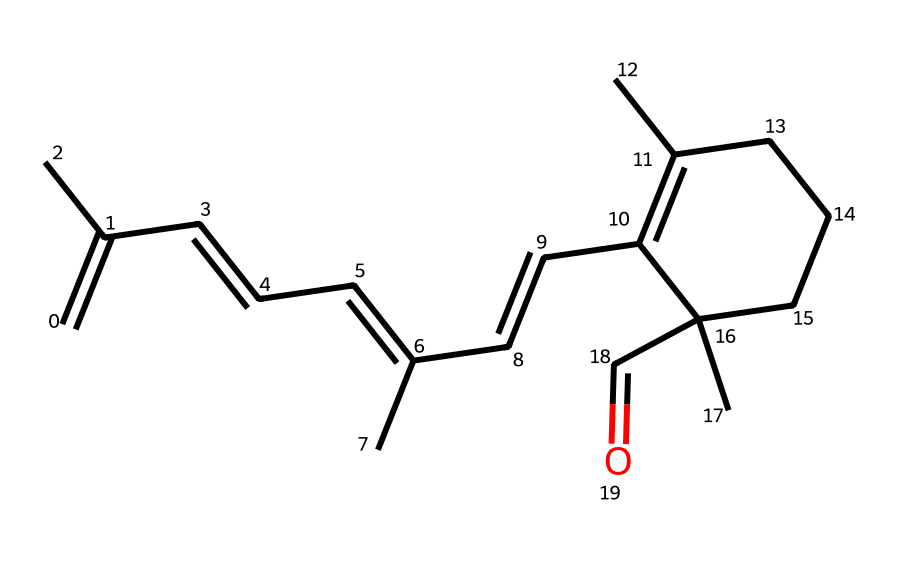What is the molecular formula of retinal? To determine the molecular formula from the SMILES representation, count the number of carbon (C), hydrogen (H), and oxygen (O) atoms. The structure has 21 carbons, 30 hydrogens, and 1 oxygen. Therefore, the molecular formula is C21H30O.
Answer: C21H30O How many double bonds are present in the structure? By analyzing the SMILES notation, we can identify the double bonds (C=C) in the structure. The structure has 5 instances of double bonds between carbon atoms.
Answer: 5 What type of functional group is present in retinal? The SMILES representation contains the fragment C=O, indicating the carbonyl group (C=O), which is characteristic of aldehydes. Thus, retinal contains an aldehyde functional group.
Answer: aldehyde What is the significance of the carbonyl carbon in retinal? The carbonyl carbon is connected to a hydrogen atom (–CHO), which defines it as an aldehyde. Aldehydes often play a crucial role in visual processes, like retinal, which is involved in vision.
Answer: visual processes Which part of the molecule indicates it is an aldehyde? The aldehyde characteristic is indicated by the terminal carbon, which has a carbonyl (C=O) group and a hydrogen (–CHO) attached to it. This configuration is typical for aldehydes.
Answer: terminal carbon What is the degree of unsaturation in retinal? To calculate the degree of unsaturation, use the formula: (number of rings + number of double bonds) = (5 double bonds + 0 rings) = 5. Thus, the degree of unsaturation is 5.
Answer: 5 